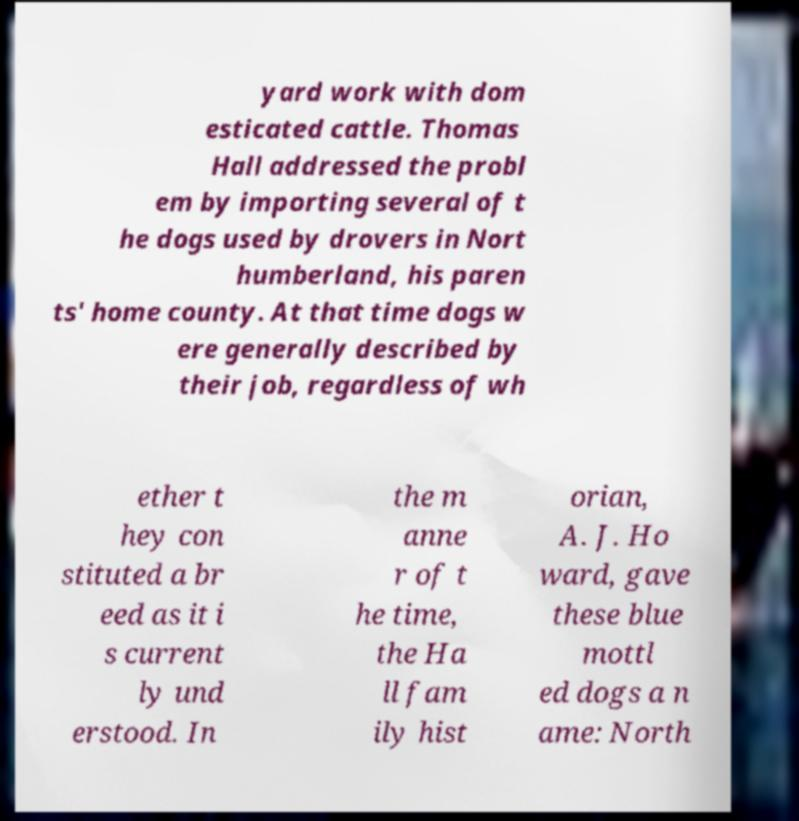Please identify and transcribe the text found in this image. yard work with dom esticated cattle. Thomas Hall addressed the probl em by importing several of t he dogs used by drovers in Nort humberland, his paren ts' home county. At that time dogs w ere generally described by their job, regardless of wh ether t hey con stituted a br eed as it i s current ly und erstood. In the m anne r of t he time, the Ha ll fam ily hist orian, A. J. Ho ward, gave these blue mottl ed dogs a n ame: North 